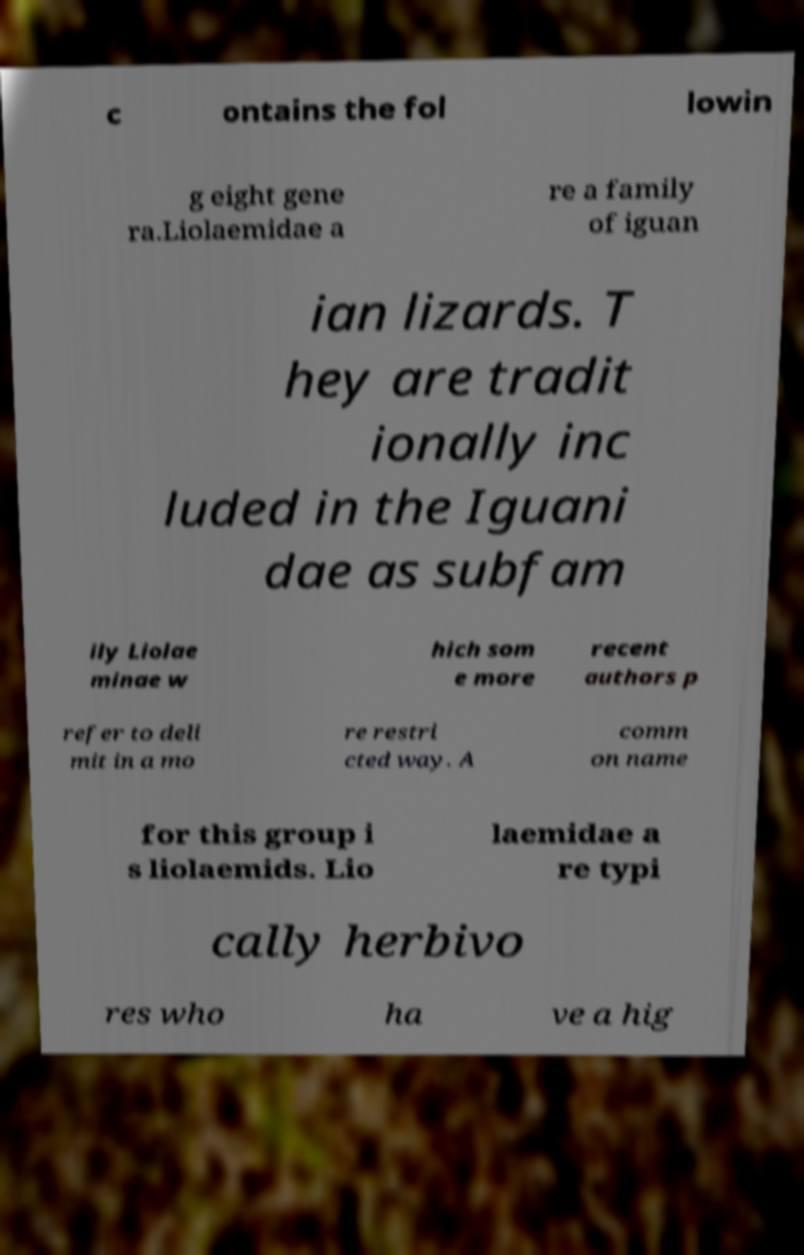Please identify and transcribe the text found in this image. c ontains the fol lowin g eight gene ra.Liolaemidae a re a family of iguan ian lizards. T hey are tradit ionally inc luded in the Iguani dae as subfam ily Liolae minae w hich som e more recent authors p refer to deli mit in a mo re restri cted way. A comm on name for this group i s liolaemids. Lio laemidae a re typi cally herbivo res who ha ve a hig 